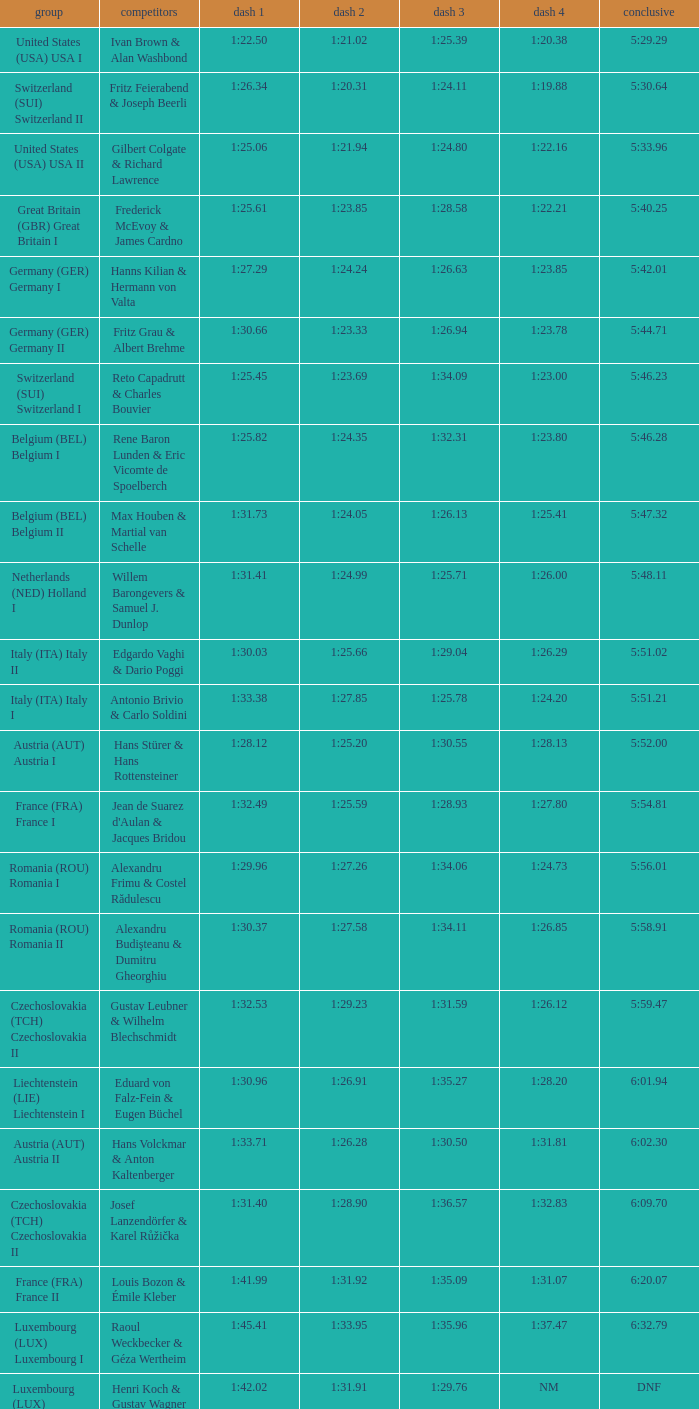Which Run 2 has a Run 1 of 1:30.03? 1:25.66. 